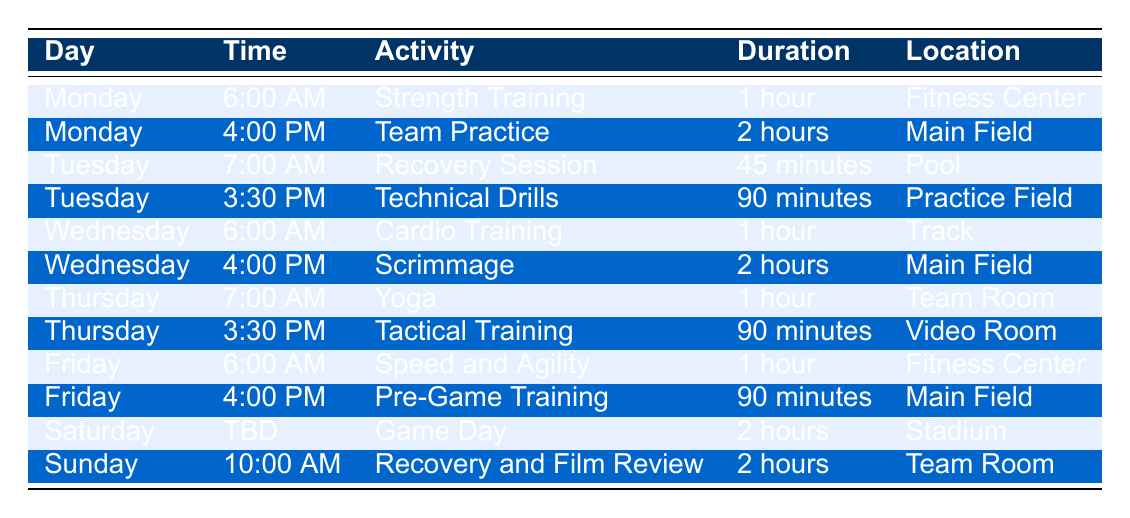What activity takes place on Wednesday at 4:00 PM? The table lists the activities scheduled for each day and time. On Wednesday, at 4:00 PM, the activity is Scrimmage.
Answer: Scrimmage How long is the Pre-Game Training session on Friday? From the table, we can see that Pre-Game Training on Friday lasts 90 minutes.
Answer: 90 minutes Is there a strength training session on Tuesday? The table shows that there isn't a strength training session on Tuesday; it lists Recovery Session and Technical Drills.
Answer: No What is the total duration of activities scheduled on Monday? On Monday, there are two activities: Strength Training (1 hour) and Team Practice (2 hours). Adding these together gives a total duration of 1 hour + 2 hours = 3 hours.
Answer: 3 hours On which day does the team have a recovery session? The table indicates that a Recovery Session is scheduled on Tuesday at 7:00 AM.
Answer: Tuesday What is the duration of the activity with the longest duration during the week? In the table, the longest activity duration is for Team Practice on Monday and Scrimmage on Wednesday, both lasting 2 hours.
Answer: 2 hours Does the team train on Saturday? The table shows that there is a Game Day scheduled for Saturday, which is classified as an activity.
Answer: Yes How many total hours of training and activities are scheduled for the week? To find the total, add the durations of all activities: 1 + 2 + 0.75 (45 mins) + 1.5 (90 mins) + 1 + 2 + 1 + 1.5 + 1 + 1.5 + 2 + 2 = 16 hours.
Answer: 16 hours What type of training is scheduled for Thursday morning? On Thursday, the training activity in the morning at 7:00 AM is Yoga.
Answer: Yoga 